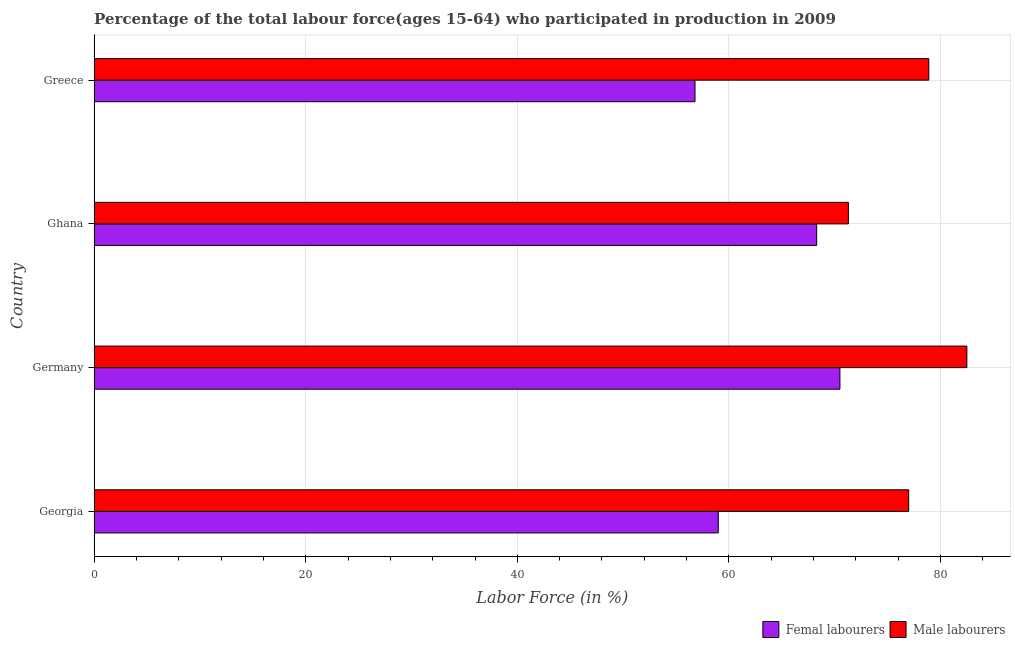How many different coloured bars are there?
Ensure brevity in your answer.  2. How many bars are there on the 1st tick from the top?
Your answer should be very brief. 2. What is the label of the 3rd group of bars from the top?
Keep it short and to the point. Germany. In how many cases, is the number of bars for a given country not equal to the number of legend labels?
Provide a short and direct response. 0. What is the percentage of male labour force in Ghana?
Provide a short and direct response. 71.3. Across all countries, what is the maximum percentage of male labour force?
Make the answer very short. 82.5. Across all countries, what is the minimum percentage of female labor force?
Provide a succinct answer. 56.8. In which country was the percentage of female labor force minimum?
Keep it short and to the point. Greece. What is the total percentage of male labour force in the graph?
Make the answer very short. 309.7. What is the difference between the percentage of female labor force in Ghana and the percentage of male labour force in Georgia?
Provide a short and direct response. -8.7. What is the average percentage of male labour force per country?
Ensure brevity in your answer.  77.42. What is the difference between the percentage of male labour force and percentage of female labor force in Greece?
Keep it short and to the point. 22.1. What is the ratio of the percentage of male labour force in Germany to that in Greece?
Provide a succinct answer. 1.05. Is the difference between the percentage of female labor force in Georgia and Germany greater than the difference between the percentage of male labour force in Georgia and Germany?
Offer a very short reply. No. What is the difference between the highest and the lowest percentage of male labour force?
Keep it short and to the point. 11.2. In how many countries, is the percentage of male labour force greater than the average percentage of male labour force taken over all countries?
Provide a short and direct response. 2. Is the sum of the percentage of male labour force in Germany and Greece greater than the maximum percentage of female labor force across all countries?
Your answer should be very brief. Yes. What does the 1st bar from the top in Ghana represents?
Provide a succinct answer. Male labourers. What does the 2nd bar from the bottom in Georgia represents?
Offer a terse response. Male labourers. Are all the bars in the graph horizontal?
Offer a terse response. Yes. How many countries are there in the graph?
Give a very brief answer. 4. Does the graph contain grids?
Your answer should be very brief. Yes. How many legend labels are there?
Ensure brevity in your answer.  2. What is the title of the graph?
Ensure brevity in your answer.  Percentage of the total labour force(ages 15-64) who participated in production in 2009. Does "Quasi money growth" appear as one of the legend labels in the graph?
Provide a succinct answer. No. What is the label or title of the X-axis?
Your response must be concise. Labor Force (in %). What is the label or title of the Y-axis?
Your response must be concise. Country. What is the Labor Force (in %) in Femal labourers in Georgia?
Keep it short and to the point. 59. What is the Labor Force (in %) of Male labourers in Georgia?
Give a very brief answer. 77. What is the Labor Force (in %) of Femal labourers in Germany?
Offer a very short reply. 70.5. What is the Labor Force (in %) in Male labourers in Germany?
Provide a short and direct response. 82.5. What is the Labor Force (in %) of Femal labourers in Ghana?
Offer a very short reply. 68.3. What is the Labor Force (in %) of Male labourers in Ghana?
Make the answer very short. 71.3. What is the Labor Force (in %) of Femal labourers in Greece?
Your answer should be very brief. 56.8. What is the Labor Force (in %) of Male labourers in Greece?
Keep it short and to the point. 78.9. Across all countries, what is the maximum Labor Force (in %) in Femal labourers?
Your response must be concise. 70.5. Across all countries, what is the maximum Labor Force (in %) of Male labourers?
Your answer should be very brief. 82.5. Across all countries, what is the minimum Labor Force (in %) of Femal labourers?
Offer a terse response. 56.8. Across all countries, what is the minimum Labor Force (in %) of Male labourers?
Offer a terse response. 71.3. What is the total Labor Force (in %) in Femal labourers in the graph?
Give a very brief answer. 254.6. What is the total Labor Force (in %) of Male labourers in the graph?
Your response must be concise. 309.7. What is the difference between the Labor Force (in %) of Femal labourers in Georgia and that in Ghana?
Provide a succinct answer. -9.3. What is the difference between the Labor Force (in %) of Male labourers in Georgia and that in Greece?
Ensure brevity in your answer.  -1.9. What is the difference between the Labor Force (in %) in Femal labourers in Germany and that in Ghana?
Offer a terse response. 2.2. What is the difference between the Labor Force (in %) of Femal labourers in Germany and that in Greece?
Give a very brief answer. 13.7. What is the difference between the Labor Force (in %) of Male labourers in Germany and that in Greece?
Offer a terse response. 3.6. What is the difference between the Labor Force (in %) of Femal labourers in Georgia and the Labor Force (in %) of Male labourers in Germany?
Ensure brevity in your answer.  -23.5. What is the difference between the Labor Force (in %) of Femal labourers in Georgia and the Labor Force (in %) of Male labourers in Ghana?
Your answer should be very brief. -12.3. What is the difference between the Labor Force (in %) in Femal labourers in Georgia and the Labor Force (in %) in Male labourers in Greece?
Ensure brevity in your answer.  -19.9. What is the difference between the Labor Force (in %) in Femal labourers in Germany and the Labor Force (in %) in Male labourers in Ghana?
Your answer should be very brief. -0.8. What is the difference between the Labor Force (in %) in Femal labourers in Germany and the Labor Force (in %) in Male labourers in Greece?
Your answer should be compact. -8.4. What is the average Labor Force (in %) in Femal labourers per country?
Give a very brief answer. 63.65. What is the average Labor Force (in %) in Male labourers per country?
Provide a short and direct response. 77.42. What is the difference between the Labor Force (in %) in Femal labourers and Labor Force (in %) in Male labourers in Germany?
Ensure brevity in your answer.  -12. What is the difference between the Labor Force (in %) in Femal labourers and Labor Force (in %) in Male labourers in Ghana?
Provide a succinct answer. -3. What is the difference between the Labor Force (in %) in Femal labourers and Labor Force (in %) in Male labourers in Greece?
Your answer should be very brief. -22.1. What is the ratio of the Labor Force (in %) of Femal labourers in Georgia to that in Germany?
Your answer should be compact. 0.84. What is the ratio of the Labor Force (in %) in Femal labourers in Georgia to that in Ghana?
Your answer should be very brief. 0.86. What is the ratio of the Labor Force (in %) of Male labourers in Georgia to that in Ghana?
Offer a very short reply. 1.08. What is the ratio of the Labor Force (in %) of Femal labourers in Georgia to that in Greece?
Give a very brief answer. 1.04. What is the ratio of the Labor Force (in %) in Male labourers in Georgia to that in Greece?
Provide a succinct answer. 0.98. What is the ratio of the Labor Force (in %) of Femal labourers in Germany to that in Ghana?
Ensure brevity in your answer.  1.03. What is the ratio of the Labor Force (in %) in Male labourers in Germany to that in Ghana?
Ensure brevity in your answer.  1.16. What is the ratio of the Labor Force (in %) of Femal labourers in Germany to that in Greece?
Your answer should be very brief. 1.24. What is the ratio of the Labor Force (in %) of Male labourers in Germany to that in Greece?
Your response must be concise. 1.05. What is the ratio of the Labor Force (in %) of Femal labourers in Ghana to that in Greece?
Make the answer very short. 1.2. What is the ratio of the Labor Force (in %) of Male labourers in Ghana to that in Greece?
Ensure brevity in your answer.  0.9. What is the difference between the highest and the second highest Labor Force (in %) of Male labourers?
Your answer should be very brief. 3.6. What is the difference between the highest and the lowest Labor Force (in %) in Femal labourers?
Offer a very short reply. 13.7. 